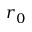Convert formula to latex. <formula><loc_0><loc_0><loc_500><loc_500>r _ { 0 }</formula> 